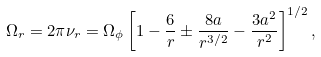<formula> <loc_0><loc_0><loc_500><loc_500>\Omega _ { r } = 2 \pi \nu _ { r } = \Omega _ { \phi } \left [ 1 - \frac { 6 } { r } \pm \frac { 8 a } { r ^ { 3 / 2 } } - \frac { 3 a ^ { 2 } } { r ^ { 2 } } \right ] ^ { 1 / 2 } ,</formula> 